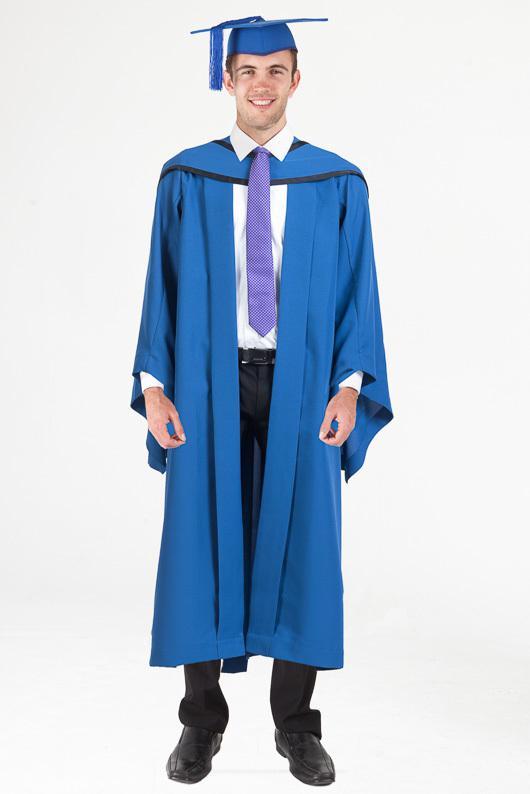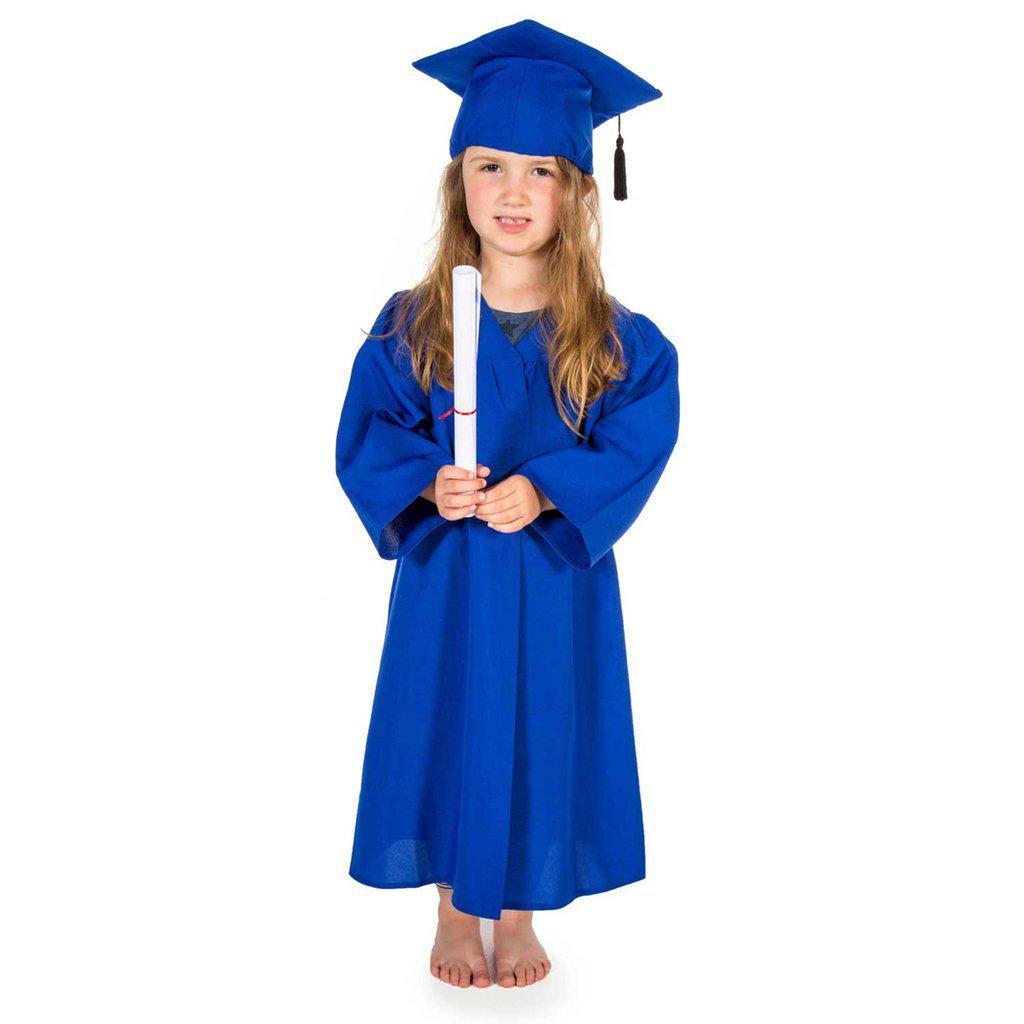The first image is the image on the left, the second image is the image on the right. Evaluate the accuracy of this statement regarding the images: "Two people are dressed in a blue graduation cap and blue graduation gown". Is it true? Answer yes or no. Yes. The first image is the image on the left, the second image is the image on the right. Examine the images to the left and right. Is the description "A young girl wears a blue graduation robe and cap in one image." accurate? Answer yes or no. Yes. 